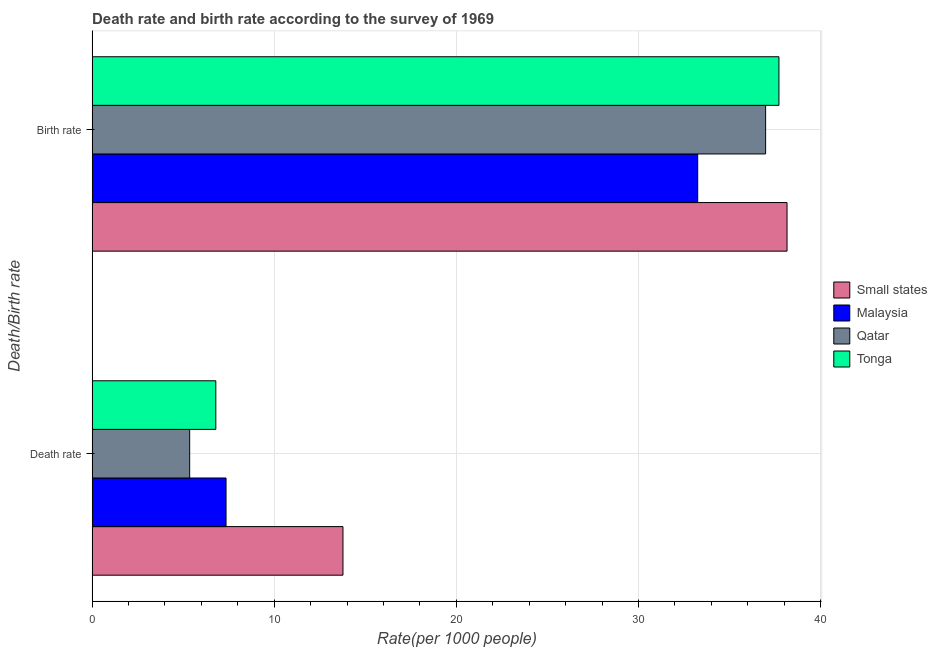How many different coloured bars are there?
Your answer should be very brief. 4. Are the number of bars per tick equal to the number of legend labels?
Your response must be concise. Yes. Are the number of bars on each tick of the Y-axis equal?
Ensure brevity in your answer.  Yes. How many bars are there on the 2nd tick from the top?
Ensure brevity in your answer.  4. What is the label of the 2nd group of bars from the top?
Ensure brevity in your answer.  Death rate. What is the death rate in Small states?
Ensure brevity in your answer.  13.77. Across all countries, what is the maximum birth rate?
Offer a terse response. 38.16. Across all countries, what is the minimum death rate?
Offer a terse response. 5.36. In which country was the death rate maximum?
Offer a terse response. Small states. In which country was the birth rate minimum?
Your answer should be compact. Malaysia. What is the total death rate in the graph?
Your response must be concise. 33.28. What is the difference between the death rate in Qatar and that in Small states?
Your answer should be compact. -8.42. What is the difference between the death rate in Tonga and the birth rate in Small states?
Give a very brief answer. -31.36. What is the average death rate per country?
Ensure brevity in your answer.  8.32. What is the difference between the death rate and birth rate in Tonga?
Provide a succinct answer. -30.92. In how many countries, is the birth rate greater than 36 ?
Provide a short and direct response. 3. What is the ratio of the birth rate in Qatar to that in Malaysia?
Keep it short and to the point. 1.11. Is the birth rate in Small states less than that in Qatar?
Keep it short and to the point. No. What does the 4th bar from the top in Death rate represents?
Make the answer very short. Small states. What does the 1st bar from the bottom in Death rate represents?
Your answer should be very brief. Small states. Are all the bars in the graph horizontal?
Give a very brief answer. Yes. How many countries are there in the graph?
Provide a succinct answer. 4. What is the difference between two consecutive major ticks on the X-axis?
Offer a very short reply. 10. Are the values on the major ticks of X-axis written in scientific E-notation?
Your answer should be very brief. No. Does the graph contain any zero values?
Your response must be concise. No. Where does the legend appear in the graph?
Give a very brief answer. Center right. How many legend labels are there?
Provide a succinct answer. 4. How are the legend labels stacked?
Offer a terse response. Vertical. What is the title of the graph?
Provide a short and direct response. Death rate and birth rate according to the survey of 1969. What is the label or title of the X-axis?
Ensure brevity in your answer.  Rate(per 1000 people). What is the label or title of the Y-axis?
Your response must be concise. Death/Birth rate. What is the Rate(per 1000 people) of Small states in Death rate?
Make the answer very short. 13.77. What is the Rate(per 1000 people) in Malaysia in Death rate?
Offer a terse response. 7.36. What is the Rate(per 1000 people) in Qatar in Death rate?
Keep it short and to the point. 5.36. What is the Rate(per 1000 people) in Tonga in Death rate?
Offer a very short reply. 6.79. What is the Rate(per 1000 people) of Small states in Birth rate?
Provide a short and direct response. 38.16. What is the Rate(per 1000 people) of Malaysia in Birth rate?
Make the answer very short. 33.25. What is the Rate(per 1000 people) in Qatar in Birth rate?
Provide a succinct answer. 36.98. What is the Rate(per 1000 people) in Tonga in Birth rate?
Your answer should be compact. 37.71. Across all Death/Birth rate, what is the maximum Rate(per 1000 people) in Small states?
Make the answer very short. 38.16. Across all Death/Birth rate, what is the maximum Rate(per 1000 people) of Malaysia?
Provide a short and direct response. 33.25. Across all Death/Birth rate, what is the maximum Rate(per 1000 people) of Qatar?
Keep it short and to the point. 36.98. Across all Death/Birth rate, what is the maximum Rate(per 1000 people) of Tonga?
Give a very brief answer. 37.71. Across all Death/Birth rate, what is the minimum Rate(per 1000 people) in Small states?
Provide a short and direct response. 13.77. Across all Death/Birth rate, what is the minimum Rate(per 1000 people) in Malaysia?
Your response must be concise. 7.36. Across all Death/Birth rate, what is the minimum Rate(per 1000 people) of Qatar?
Your answer should be very brief. 5.36. Across all Death/Birth rate, what is the minimum Rate(per 1000 people) in Tonga?
Keep it short and to the point. 6.79. What is the total Rate(per 1000 people) of Small states in the graph?
Provide a succinct answer. 51.93. What is the total Rate(per 1000 people) of Malaysia in the graph?
Give a very brief answer. 40.61. What is the total Rate(per 1000 people) in Qatar in the graph?
Offer a terse response. 42.34. What is the total Rate(per 1000 people) of Tonga in the graph?
Provide a short and direct response. 44.51. What is the difference between the Rate(per 1000 people) of Small states in Death rate and that in Birth rate?
Offer a very short reply. -24.38. What is the difference between the Rate(per 1000 people) of Malaysia in Death rate and that in Birth rate?
Ensure brevity in your answer.  -25.9. What is the difference between the Rate(per 1000 people) in Qatar in Death rate and that in Birth rate?
Give a very brief answer. -31.62. What is the difference between the Rate(per 1000 people) of Tonga in Death rate and that in Birth rate?
Keep it short and to the point. -30.92. What is the difference between the Rate(per 1000 people) in Small states in Death rate and the Rate(per 1000 people) in Malaysia in Birth rate?
Ensure brevity in your answer.  -19.48. What is the difference between the Rate(per 1000 people) in Small states in Death rate and the Rate(per 1000 people) in Qatar in Birth rate?
Your response must be concise. -23.21. What is the difference between the Rate(per 1000 people) in Small states in Death rate and the Rate(per 1000 people) in Tonga in Birth rate?
Offer a terse response. -23.94. What is the difference between the Rate(per 1000 people) of Malaysia in Death rate and the Rate(per 1000 people) of Qatar in Birth rate?
Your response must be concise. -29.63. What is the difference between the Rate(per 1000 people) of Malaysia in Death rate and the Rate(per 1000 people) of Tonga in Birth rate?
Your answer should be very brief. -30.36. What is the difference between the Rate(per 1000 people) in Qatar in Death rate and the Rate(per 1000 people) in Tonga in Birth rate?
Provide a succinct answer. -32.35. What is the average Rate(per 1000 people) in Small states per Death/Birth rate?
Make the answer very short. 25.97. What is the average Rate(per 1000 people) of Malaysia per Death/Birth rate?
Make the answer very short. 20.3. What is the average Rate(per 1000 people) of Qatar per Death/Birth rate?
Your response must be concise. 21.17. What is the average Rate(per 1000 people) of Tonga per Death/Birth rate?
Give a very brief answer. 22.25. What is the difference between the Rate(per 1000 people) in Small states and Rate(per 1000 people) in Malaysia in Death rate?
Provide a short and direct response. 6.42. What is the difference between the Rate(per 1000 people) of Small states and Rate(per 1000 people) of Qatar in Death rate?
Make the answer very short. 8.42. What is the difference between the Rate(per 1000 people) of Small states and Rate(per 1000 people) of Tonga in Death rate?
Your answer should be very brief. 6.98. What is the difference between the Rate(per 1000 people) in Malaysia and Rate(per 1000 people) in Qatar in Death rate?
Your response must be concise. 2. What is the difference between the Rate(per 1000 people) of Malaysia and Rate(per 1000 people) of Tonga in Death rate?
Give a very brief answer. 0.56. What is the difference between the Rate(per 1000 people) of Qatar and Rate(per 1000 people) of Tonga in Death rate?
Your answer should be very brief. -1.44. What is the difference between the Rate(per 1000 people) of Small states and Rate(per 1000 people) of Malaysia in Birth rate?
Your response must be concise. 4.9. What is the difference between the Rate(per 1000 people) of Small states and Rate(per 1000 people) of Qatar in Birth rate?
Offer a very short reply. 1.17. What is the difference between the Rate(per 1000 people) in Small states and Rate(per 1000 people) in Tonga in Birth rate?
Make the answer very short. 0.44. What is the difference between the Rate(per 1000 people) in Malaysia and Rate(per 1000 people) in Qatar in Birth rate?
Your answer should be very brief. -3.73. What is the difference between the Rate(per 1000 people) in Malaysia and Rate(per 1000 people) in Tonga in Birth rate?
Your answer should be compact. -4.46. What is the difference between the Rate(per 1000 people) in Qatar and Rate(per 1000 people) in Tonga in Birth rate?
Make the answer very short. -0.73. What is the ratio of the Rate(per 1000 people) of Small states in Death rate to that in Birth rate?
Provide a succinct answer. 0.36. What is the ratio of the Rate(per 1000 people) in Malaysia in Death rate to that in Birth rate?
Keep it short and to the point. 0.22. What is the ratio of the Rate(per 1000 people) of Qatar in Death rate to that in Birth rate?
Provide a short and direct response. 0.14. What is the ratio of the Rate(per 1000 people) in Tonga in Death rate to that in Birth rate?
Give a very brief answer. 0.18. What is the difference between the highest and the second highest Rate(per 1000 people) of Small states?
Give a very brief answer. 24.38. What is the difference between the highest and the second highest Rate(per 1000 people) in Malaysia?
Your answer should be compact. 25.9. What is the difference between the highest and the second highest Rate(per 1000 people) of Qatar?
Ensure brevity in your answer.  31.62. What is the difference between the highest and the second highest Rate(per 1000 people) in Tonga?
Your response must be concise. 30.92. What is the difference between the highest and the lowest Rate(per 1000 people) in Small states?
Make the answer very short. 24.38. What is the difference between the highest and the lowest Rate(per 1000 people) of Malaysia?
Give a very brief answer. 25.9. What is the difference between the highest and the lowest Rate(per 1000 people) of Qatar?
Ensure brevity in your answer.  31.62. What is the difference between the highest and the lowest Rate(per 1000 people) in Tonga?
Provide a succinct answer. 30.92. 